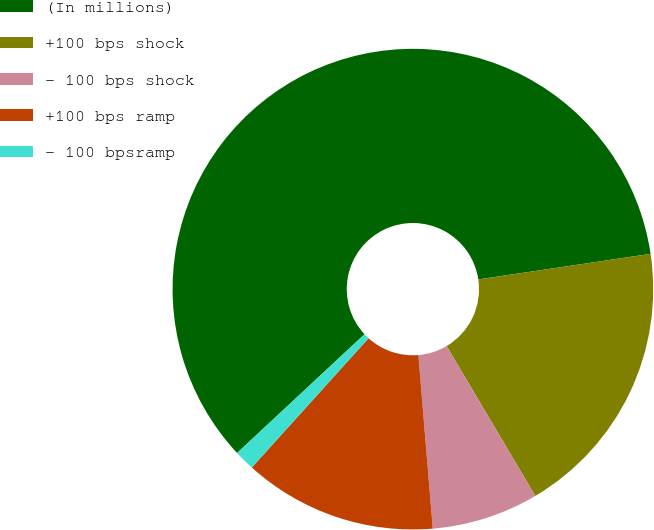Convert chart to OTSL. <chart><loc_0><loc_0><loc_500><loc_500><pie_chart><fcel>(In millions)<fcel>+100 bps shock<fcel>- 100 bps shock<fcel>+100 bps ramp<fcel>- 100 bpsramp<nl><fcel>59.6%<fcel>18.84%<fcel>7.19%<fcel>13.01%<fcel>1.37%<nl></chart> 